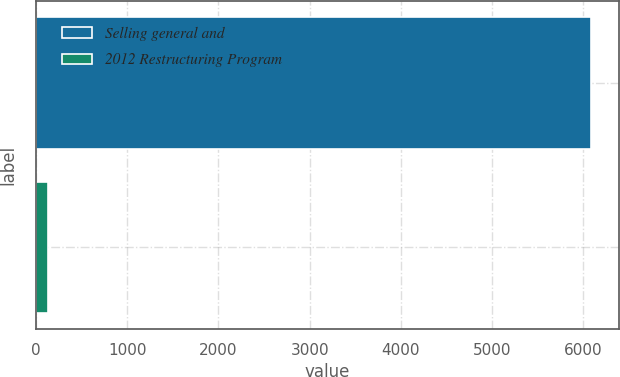Convert chart. <chart><loc_0><loc_0><loc_500><loc_500><bar_chart><fcel>Selling general and<fcel>2012 Restructuring Program<nl><fcel>6086<fcel>137<nl></chart> 